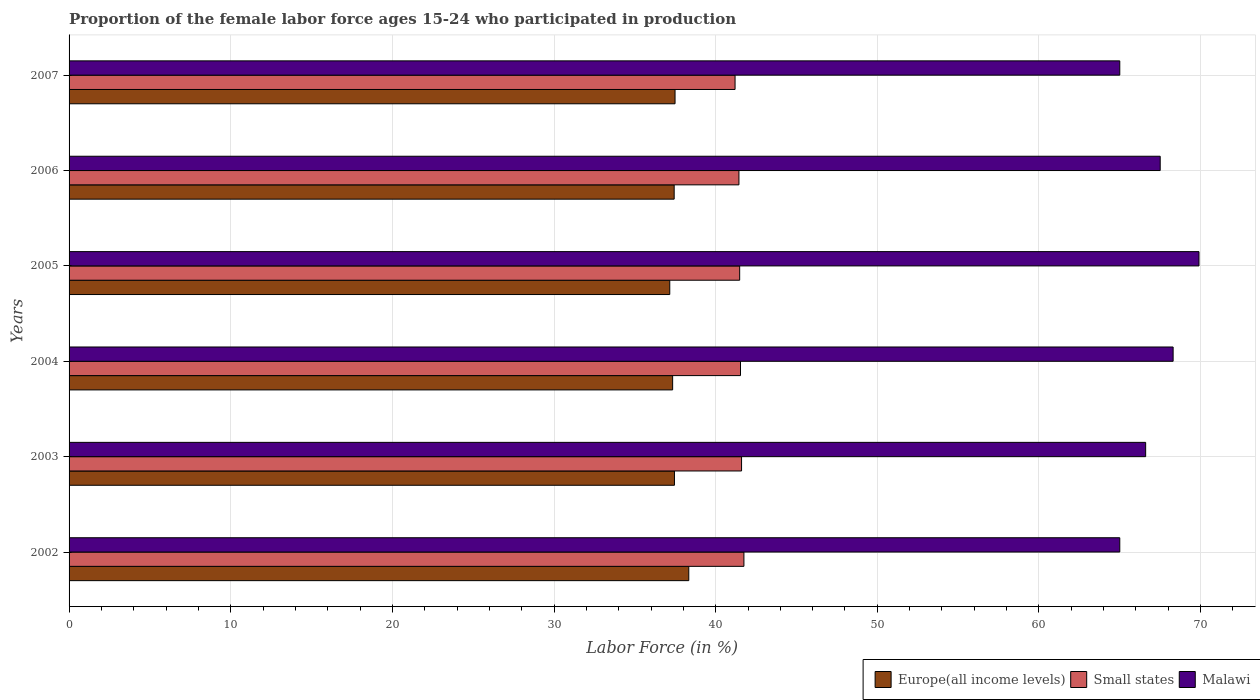How many different coloured bars are there?
Offer a very short reply. 3. How many groups of bars are there?
Keep it short and to the point. 6. How many bars are there on the 5th tick from the top?
Provide a short and direct response. 3. What is the proportion of the female labor force who participated in production in Small states in 2003?
Your answer should be very brief. 41.6. Across all years, what is the maximum proportion of the female labor force who participated in production in Small states?
Ensure brevity in your answer.  41.75. Across all years, what is the minimum proportion of the female labor force who participated in production in Europe(all income levels)?
Your response must be concise. 37.16. In which year was the proportion of the female labor force who participated in production in Europe(all income levels) minimum?
Your answer should be compact. 2005. What is the total proportion of the female labor force who participated in production in Small states in the graph?
Offer a very short reply. 249.01. What is the difference between the proportion of the female labor force who participated in production in Europe(all income levels) in 2005 and that in 2007?
Provide a short and direct response. -0.33. What is the difference between the proportion of the female labor force who participated in production in Small states in 2005 and the proportion of the female labor force who participated in production in Malawi in 2007?
Make the answer very short. -23.51. What is the average proportion of the female labor force who participated in production in Europe(all income levels) per year?
Your answer should be very brief. 37.53. In the year 2005, what is the difference between the proportion of the female labor force who participated in production in Small states and proportion of the female labor force who participated in production in Malawi?
Give a very brief answer. -28.41. What is the ratio of the proportion of the female labor force who participated in production in Small states in 2002 to that in 2006?
Keep it short and to the point. 1.01. Is the proportion of the female labor force who participated in production in Europe(all income levels) in 2004 less than that in 2006?
Offer a very short reply. Yes. Is the difference between the proportion of the female labor force who participated in production in Small states in 2002 and 2004 greater than the difference between the proportion of the female labor force who participated in production in Malawi in 2002 and 2004?
Offer a very short reply. Yes. What is the difference between the highest and the second highest proportion of the female labor force who participated in production in Europe(all income levels)?
Offer a very short reply. 0.85. What is the difference between the highest and the lowest proportion of the female labor force who participated in production in Europe(all income levels)?
Provide a succinct answer. 1.18. In how many years, is the proportion of the female labor force who participated in production in Europe(all income levels) greater than the average proportion of the female labor force who participated in production in Europe(all income levels) taken over all years?
Your answer should be compact. 1. Is the sum of the proportion of the female labor force who participated in production in Europe(all income levels) in 2004 and 2007 greater than the maximum proportion of the female labor force who participated in production in Small states across all years?
Ensure brevity in your answer.  Yes. What does the 2nd bar from the top in 2007 represents?
Your answer should be very brief. Small states. What does the 1st bar from the bottom in 2002 represents?
Offer a terse response. Europe(all income levels). How many bars are there?
Make the answer very short. 18. Are all the bars in the graph horizontal?
Ensure brevity in your answer.  Yes. How many years are there in the graph?
Keep it short and to the point. 6. Are the values on the major ticks of X-axis written in scientific E-notation?
Your answer should be very brief. No. Where does the legend appear in the graph?
Provide a succinct answer. Bottom right. What is the title of the graph?
Keep it short and to the point. Proportion of the female labor force ages 15-24 who participated in production. What is the Labor Force (in %) of Europe(all income levels) in 2002?
Offer a terse response. 38.34. What is the Labor Force (in %) of Small states in 2002?
Keep it short and to the point. 41.75. What is the Labor Force (in %) of Europe(all income levels) in 2003?
Provide a succinct answer. 37.45. What is the Labor Force (in %) in Small states in 2003?
Your answer should be very brief. 41.6. What is the Labor Force (in %) in Malawi in 2003?
Keep it short and to the point. 66.6. What is the Labor Force (in %) of Europe(all income levels) in 2004?
Keep it short and to the point. 37.34. What is the Labor Force (in %) in Small states in 2004?
Offer a terse response. 41.54. What is the Labor Force (in %) of Malawi in 2004?
Ensure brevity in your answer.  68.3. What is the Labor Force (in %) in Europe(all income levels) in 2005?
Provide a short and direct response. 37.16. What is the Labor Force (in %) of Small states in 2005?
Give a very brief answer. 41.49. What is the Labor Force (in %) in Malawi in 2005?
Your answer should be compact. 69.9. What is the Labor Force (in %) of Europe(all income levels) in 2006?
Offer a terse response. 37.43. What is the Labor Force (in %) in Small states in 2006?
Make the answer very short. 41.44. What is the Labor Force (in %) in Malawi in 2006?
Give a very brief answer. 67.5. What is the Labor Force (in %) in Europe(all income levels) in 2007?
Make the answer very short. 37.49. What is the Labor Force (in %) in Small states in 2007?
Make the answer very short. 41.2. Across all years, what is the maximum Labor Force (in %) in Europe(all income levels)?
Your response must be concise. 38.34. Across all years, what is the maximum Labor Force (in %) of Small states?
Your answer should be very brief. 41.75. Across all years, what is the maximum Labor Force (in %) of Malawi?
Your answer should be compact. 69.9. Across all years, what is the minimum Labor Force (in %) in Europe(all income levels)?
Give a very brief answer. 37.16. Across all years, what is the minimum Labor Force (in %) of Small states?
Your response must be concise. 41.2. What is the total Labor Force (in %) in Europe(all income levels) in the graph?
Provide a succinct answer. 225.21. What is the total Labor Force (in %) of Small states in the graph?
Make the answer very short. 249.01. What is the total Labor Force (in %) of Malawi in the graph?
Give a very brief answer. 402.3. What is the difference between the Labor Force (in %) of Europe(all income levels) in 2002 and that in 2003?
Give a very brief answer. 0.89. What is the difference between the Labor Force (in %) of Small states in 2002 and that in 2003?
Provide a succinct answer. 0.15. What is the difference between the Labor Force (in %) in Small states in 2002 and that in 2004?
Offer a very short reply. 0.21. What is the difference between the Labor Force (in %) in Malawi in 2002 and that in 2004?
Your answer should be very brief. -3.3. What is the difference between the Labor Force (in %) of Europe(all income levels) in 2002 and that in 2005?
Offer a terse response. 1.18. What is the difference between the Labor Force (in %) of Small states in 2002 and that in 2005?
Offer a terse response. 0.26. What is the difference between the Labor Force (in %) in Europe(all income levels) in 2002 and that in 2006?
Your answer should be very brief. 0.9. What is the difference between the Labor Force (in %) of Small states in 2002 and that in 2006?
Keep it short and to the point. 0.31. What is the difference between the Labor Force (in %) of Malawi in 2002 and that in 2006?
Your response must be concise. -2.5. What is the difference between the Labor Force (in %) in Europe(all income levels) in 2002 and that in 2007?
Make the answer very short. 0.85. What is the difference between the Labor Force (in %) in Small states in 2002 and that in 2007?
Ensure brevity in your answer.  0.55. What is the difference between the Labor Force (in %) in Europe(all income levels) in 2003 and that in 2004?
Provide a succinct answer. 0.11. What is the difference between the Labor Force (in %) of Small states in 2003 and that in 2004?
Ensure brevity in your answer.  0.07. What is the difference between the Labor Force (in %) in Europe(all income levels) in 2003 and that in 2005?
Keep it short and to the point. 0.29. What is the difference between the Labor Force (in %) in Small states in 2003 and that in 2005?
Your answer should be compact. 0.12. What is the difference between the Labor Force (in %) in Europe(all income levels) in 2003 and that in 2006?
Keep it short and to the point. 0.02. What is the difference between the Labor Force (in %) in Small states in 2003 and that in 2006?
Your answer should be compact. 0.16. What is the difference between the Labor Force (in %) in Malawi in 2003 and that in 2006?
Ensure brevity in your answer.  -0.9. What is the difference between the Labor Force (in %) in Europe(all income levels) in 2003 and that in 2007?
Provide a succinct answer. -0.04. What is the difference between the Labor Force (in %) of Small states in 2003 and that in 2007?
Your answer should be very brief. 0.4. What is the difference between the Labor Force (in %) of Europe(all income levels) in 2004 and that in 2005?
Offer a very short reply. 0.18. What is the difference between the Labor Force (in %) in Small states in 2004 and that in 2005?
Your response must be concise. 0.05. What is the difference between the Labor Force (in %) in Malawi in 2004 and that in 2005?
Your answer should be compact. -1.6. What is the difference between the Labor Force (in %) of Europe(all income levels) in 2004 and that in 2006?
Provide a succinct answer. -0.09. What is the difference between the Labor Force (in %) in Small states in 2004 and that in 2006?
Your answer should be compact. 0.1. What is the difference between the Labor Force (in %) in Malawi in 2004 and that in 2006?
Give a very brief answer. 0.8. What is the difference between the Labor Force (in %) of Europe(all income levels) in 2004 and that in 2007?
Give a very brief answer. -0.15. What is the difference between the Labor Force (in %) of Small states in 2004 and that in 2007?
Give a very brief answer. 0.34. What is the difference between the Labor Force (in %) in Malawi in 2004 and that in 2007?
Offer a terse response. 3.3. What is the difference between the Labor Force (in %) of Europe(all income levels) in 2005 and that in 2006?
Your answer should be compact. -0.27. What is the difference between the Labor Force (in %) in Small states in 2005 and that in 2006?
Provide a succinct answer. 0.05. What is the difference between the Labor Force (in %) in Europe(all income levels) in 2005 and that in 2007?
Your answer should be very brief. -0.33. What is the difference between the Labor Force (in %) in Small states in 2005 and that in 2007?
Your answer should be compact. 0.29. What is the difference between the Labor Force (in %) of Malawi in 2005 and that in 2007?
Your answer should be compact. 4.9. What is the difference between the Labor Force (in %) of Europe(all income levels) in 2006 and that in 2007?
Provide a succinct answer. -0.05. What is the difference between the Labor Force (in %) of Small states in 2006 and that in 2007?
Offer a terse response. 0.24. What is the difference between the Labor Force (in %) of Malawi in 2006 and that in 2007?
Your response must be concise. 2.5. What is the difference between the Labor Force (in %) of Europe(all income levels) in 2002 and the Labor Force (in %) of Small states in 2003?
Ensure brevity in your answer.  -3.27. What is the difference between the Labor Force (in %) in Europe(all income levels) in 2002 and the Labor Force (in %) in Malawi in 2003?
Provide a short and direct response. -28.26. What is the difference between the Labor Force (in %) in Small states in 2002 and the Labor Force (in %) in Malawi in 2003?
Your response must be concise. -24.85. What is the difference between the Labor Force (in %) of Europe(all income levels) in 2002 and the Labor Force (in %) of Small states in 2004?
Your answer should be compact. -3.2. What is the difference between the Labor Force (in %) of Europe(all income levels) in 2002 and the Labor Force (in %) of Malawi in 2004?
Give a very brief answer. -29.96. What is the difference between the Labor Force (in %) in Small states in 2002 and the Labor Force (in %) in Malawi in 2004?
Your response must be concise. -26.55. What is the difference between the Labor Force (in %) of Europe(all income levels) in 2002 and the Labor Force (in %) of Small states in 2005?
Offer a terse response. -3.15. What is the difference between the Labor Force (in %) in Europe(all income levels) in 2002 and the Labor Force (in %) in Malawi in 2005?
Provide a short and direct response. -31.56. What is the difference between the Labor Force (in %) in Small states in 2002 and the Labor Force (in %) in Malawi in 2005?
Provide a succinct answer. -28.15. What is the difference between the Labor Force (in %) of Europe(all income levels) in 2002 and the Labor Force (in %) of Small states in 2006?
Ensure brevity in your answer.  -3.1. What is the difference between the Labor Force (in %) of Europe(all income levels) in 2002 and the Labor Force (in %) of Malawi in 2006?
Make the answer very short. -29.16. What is the difference between the Labor Force (in %) in Small states in 2002 and the Labor Force (in %) in Malawi in 2006?
Provide a short and direct response. -25.75. What is the difference between the Labor Force (in %) in Europe(all income levels) in 2002 and the Labor Force (in %) in Small states in 2007?
Your answer should be very brief. -2.86. What is the difference between the Labor Force (in %) of Europe(all income levels) in 2002 and the Labor Force (in %) of Malawi in 2007?
Offer a terse response. -26.66. What is the difference between the Labor Force (in %) of Small states in 2002 and the Labor Force (in %) of Malawi in 2007?
Offer a very short reply. -23.25. What is the difference between the Labor Force (in %) in Europe(all income levels) in 2003 and the Labor Force (in %) in Small states in 2004?
Provide a succinct answer. -4.09. What is the difference between the Labor Force (in %) in Europe(all income levels) in 2003 and the Labor Force (in %) in Malawi in 2004?
Your response must be concise. -30.85. What is the difference between the Labor Force (in %) of Small states in 2003 and the Labor Force (in %) of Malawi in 2004?
Provide a succinct answer. -26.7. What is the difference between the Labor Force (in %) in Europe(all income levels) in 2003 and the Labor Force (in %) in Small states in 2005?
Offer a terse response. -4.03. What is the difference between the Labor Force (in %) in Europe(all income levels) in 2003 and the Labor Force (in %) in Malawi in 2005?
Keep it short and to the point. -32.45. What is the difference between the Labor Force (in %) in Small states in 2003 and the Labor Force (in %) in Malawi in 2005?
Provide a short and direct response. -28.3. What is the difference between the Labor Force (in %) in Europe(all income levels) in 2003 and the Labor Force (in %) in Small states in 2006?
Offer a very short reply. -3.99. What is the difference between the Labor Force (in %) of Europe(all income levels) in 2003 and the Labor Force (in %) of Malawi in 2006?
Provide a short and direct response. -30.05. What is the difference between the Labor Force (in %) in Small states in 2003 and the Labor Force (in %) in Malawi in 2006?
Offer a terse response. -25.9. What is the difference between the Labor Force (in %) of Europe(all income levels) in 2003 and the Labor Force (in %) of Small states in 2007?
Offer a very short reply. -3.75. What is the difference between the Labor Force (in %) of Europe(all income levels) in 2003 and the Labor Force (in %) of Malawi in 2007?
Your response must be concise. -27.55. What is the difference between the Labor Force (in %) in Small states in 2003 and the Labor Force (in %) in Malawi in 2007?
Offer a terse response. -23.4. What is the difference between the Labor Force (in %) in Europe(all income levels) in 2004 and the Labor Force (in %) in Small states in 2005?
Your answer should be very brief. -4.15. What is the difference between the Labor Force (in %) of Europe(all income levels) in 2004 and the Labor Force (in %) of Malawi in 2005?
Your answer should be compact. -32.56. What is the difference between the Labor Force (in %) of Small states in 2004 and the Labor Force (in %) of Malawi in 2005?
Keep it short and to the point. -28.36. What is the difference between the Labor Force (in %) of Europe(all income levels) in 2004 and the Labor Force (in %) of Small states in 2006?
Keep it short and to the point. -4.1. What is the difference between the Labor Force (in %) of Europe(all income levels) in 2004 and the Labor Force (in %) of Malawi in 2006?
Offer a very short reply. -30.16. What is the difference between the Labor Force (in %) in Small states in 2004 and the Labor Force (in %) in Malawi in 2006?
Your answer should be very brief. -25.96. What is the difference between the Labor Force (in %) in Europe(all income levels) in 2004 and the Labor Force (in %) in Small states in 2007?
Provide a succinct answer. -3.86. What is the difference between the Labor Force (in %) in Europe(all income levels) in 2004 and the Labor Force (in %) in Malawi in 2007?
Your answer should be very brief. -27.66. What is the difference between the Labor Force (in %) of Small states in 2004 and the Labor Force (in %) of Malawi in 2007?
Ensure brevity in your answer.  -23.46. What is the difference between the Labor Force (in %) in Europe(all income levels) in 2005 and the Labor Force (in %) in Small states in 2006?
Your answer should be compact. -4.28. What is the difference between the Labor Force (in %) of Europe(all income levels) in 2005 and the Labor Force (in %) of Malawi in 2006?
Provide a succinct answer. -30.34. What is the difference between the Labor Force (in %) in Small states in 2005 and the Labor Force (in %) in Malawi in 2006?
Make the answer very short. -26.01. What is the difference between the Labor Force (in %) of Europe(all income levels) in 2005 and the Labor Force (in %) of Small states in 2007?
Keep it short and to the point. -4.04. What is the difference between the Labor Force (in %) of Europe(all income levels) in 2005 and the Labor Force (in %) of Malawi in 2007?
Your response must be concise. -27.84. What is the difference between the Labor Force (in %) in Small states in 2005 and the Labor Force (in %) in Malawi in 2007?
Offer a terse response. -23.51. What is the difference between the Labor Force (in %) in Europe(all income levels) in 2006 and the Labor Force (in %) in Small states in 2007?
Your response must be concise. -3.77. What is the difference between the Labor Force (in %) of Europe(all income levels) in 2006 and the Labor Force (in %) of Malawi in 2007?
Your answer should be compact. -27.57. What is the difference between the Labor Force (in %) of Small states in 2006 and the Labor Force (in %) of Malawi in 2007?
Offer a very short reply. -23.56. What is the average Labor Force (in %) in Europe(all income levels) per year?
Your answer should be very brief. 37.53. What is the average Labor Force (in %) in Small states per year?
Your response must be concise. 41.5. What is the average Labor Force (in %) of Malawi per year?
Provide a succinct answer. 67.05. In the year 2002, what is the difference between the Labor Force (in %) of Europe(all income levels) and Labor Force (in %) of Small states?
Give a very brief answer. -3.41. In the year 2002, what is the difference between the Labor Force (in %) of Europe(all income levels) and Labor Force (in %) of Malawi?
Make the answer very short. -26.66. In the year 2002, what is the difference between the Labor Force (in %) in Small states and Labor Force (in %) in Malawi?
Provide a short and direct response. -23.25. In the year 2003, what is the difference between the Labor Force (in %) of Europe(all income levels) and Labor Force (in %) of Small states?
Give a very brief answer. -4.15. In the year 2003, what is the difference between the Labor Force (in %) in Europe(all income levels) and Labor Force (in %) in Malawi?
Give a very brief answer. -29.15. In the year 2003, what is the difference between the Labor Force (in %) of Small states and Labor Force (in %) of Malawi?
Give a very brief answer. -25. In the year 2004, what is the difference between the Labor Force (in %) in Europe(all income levels) and Labor Force (in %) in Small states?
Provide a short and direct response. -4.2. In the year 2004, what is the difference between the Labor Force (in %) in Europe(all income levels) and Labor Force (in %) in Malawi?
Provide a short and direct response. -30.96. In the year 2004, what is the difference between the Labor Force (in %) of Small states and Labor Force (in %) of Malawi?
Your response must be concise. -26.76. In the year 2005, what is the difference between the Labor Force (in %) of Europe(all income levels) and Labor Force (in %) of Small states?
Provide a short and direct response. -4.32. In the year 2005, what is the difference between the Labor Force (in %) in Europe(all income levels) and Labor Force (in %) in Malawi?
Make the answer very short. -32.74. In the year 2005, what is the difference between the Labor Force (in %) of Small states and Labor Force (in %) of Malawi?
Provide a short and direct response. -28.41. In the year 2006, what is the difference between the Labor Force (in %) of Europe(all income levels) and Labor Force (in %) of Small states?
Make the answer very short. -4.01. In the year 2006, what is the difference between the Labor Force (in %) in Europe(all income levels) and Labor Force (in %) in Malawi?
Your answer should be very brief. -30.07. In the year 2006, what is the difference between the Labor Force (in %) of Small states and Labor Force (in %) of Malawi?
Your response must be concise. -26.06. In the year 2007, what is the difference between the Labor Force (in %) of Europe(all income levels) and Labor Force (in %) of Small states?
Offer a very short reply. -3.71. In the year 2007, what is the difference between the Labor Force (in %) of Europe(all income levels) and Labor Force (in %) of Malawi?
Ensure brevity in your answer.  -27.51. In the year 2007, what is the difference between the Labor Force (in %) in Small states and Labor Force (in %) in Malawi?
Make the answer very short. -23.8. What is the ratio of the Labor Force (in %) of Europe(all income levels) in 2002 to that in 2003?
Your answer should be very brief. 1.02. What is the ratio of the Labor Force (in %) in Small states in 2002 to that in 2003?
Offer a terse response. 1. What is the ratio of the Labor Force (in %) in Europe(all income levels) in 2002 to that in 2004?
Your answer should be compact. 1.03. What is the ratio of the Labor Force (in %) in Small states in 2002 to that in 2004?
Provide a succinct answer. 1.01. What is the ratio of the Labor Force (in %) of Malawi in 2002 to that in 2004?
Provide a succinct answer. 0.95. What is the ratio of the Labor Force (in %) in Europe(all income levels) in 2002 to that in 2005?
Provide a succinct answer. 1.03. What is the ratio of the Labor Force (in %) of Malawi in 2002 to that in 2005?
Your answer should be very brief. 0.93. What is the ratio of the Labor Force (in %) in Europe(all income levels) in 2002 to that in 2006?
Your response must be concise. 1.02. What is the ratio of the Labor Force (in %) of Small states in 2002 to that in 2006?
Make the answer very short. 1.01. What is the ratio of the Labor Force (in %) in Europe(all income levels) in 2002 to that in 2007?
Offer a terse response. 1.02. What is the ratio of the Labor Force (in %) in Small states in 2002 to that in 2007?
Make the answer very short. 1.01. What is the ratio of the Labor Force (in %) of Malawi in 2002 to that in 2007?
Give a very brief answer. 1. What is the ratio of the Labor Force (in %) in Europe(all income levels) in 2003 to that in 2004?
Make the answer very short. 1. What is the ratio of the Labor Force (in %) in Malawi in 2003 to that in 2004?
Offer a very short reply. 0.98. What is the ratio of the Labor Force (in %) in Europe(all income levels) in 2003 to that in 2005?
Ensure brevity in your answer.  1.01. What is the ratio of the Labor Force (in %) of Small states in 2003 to that in 2005?
Make the answer very short. 1. What is the ratio of the Labor Force (in %) in Malawi in 2003 to that in 2005?
Keep it short and to the point. 0.95. What is the ratio of the Labor Force (in %) of Europe(all income levels) in 2003 to that in 2006?
Give a very brief answer. 1. What is the ratio of the Labor Force (in %) in Malawi in 2003 to that in 2006?
Provide a succinct answer. 0.99. What is the ratio of the Labor Force (in %) of Europe(all income levels) in 2003 to that in 2007?
Ensure brevity in your answer.  1. What is the ratio of the Labor Force (in %) in Small states in 2003 to that in 2007?
Give a very brief answer. 1.01. What is the ratio of the Labor Force (in %) in Malawi in 2003 to that in 2007?
Your answer should be very brief. 1.02. What is the ratio of the Labor Force (in %) of Europe(all income levels) in 2004 to that in 2005?
Ensure brevity in your answer.  1. What is the ratio of the Labor Force (in %) of Malawi in 2004 to that in 2005?
Offer a very short reply. 0.98. What is the ratio of the Labor Force (in %) of Malawi in 2004 to that in 2006?
Provide a succinct answer. 1.01. What is the ratio of the Labor Force (in %) in Europe(all income levels) in 2004 to that in 2007?
Offer a very short reply. 1. What is the ratio of the Labor Force (in %) of Small states in 2004 to that in 2007?
Keep it short and to the point. 1.01. What is the ratio of the Labor Force (in %) in Malawi in 2004 to that in 2007?
Provide a short and direct response. 1.05. What is the ratio of the Labor Force (in %) of Malawi in 2005 to that in 2006?
Offer a very short reply. 1.04. What is the ratio of the Labor Force (in %) in Small states in 2005 to that in 2007?
Offer a very short reply. 1.01. What is the ratio of the Labor Force (in %) of Malawi in 2005 to that in 2007?
Keep it short and to the point. 1.08. What is the ratio of the Labor Force (in %) in Europe(all income levels) in 2006 to that in 2007?
Provide a succinct answer. 1. What is the ratio of the Labor Force (in %) in Malawi in 2006 to that in 2007?
Offer a very short reply. 1.04. What is the difference between the highest and the second highest Labor Force (in %) of Europe(all income levels)?
Offer a terse response. 0.85. What is the difference between the highest and the second highest Labor Force (in %) in Small states?
Offer a very short reply. 0.15. What is the difference between the highest and the lowest Labor Force (in %) of Europe(all income levels)?
Provide a short and direct response. 1.18. What is the difference between the highest and the lowest Labor Force (in %) of Small states?
Your answer should be very brief. 0.55. What is the difference between the highest and the lowest Labor Force (in %) in Malawi?
Your answer should be compact. 4.9. 